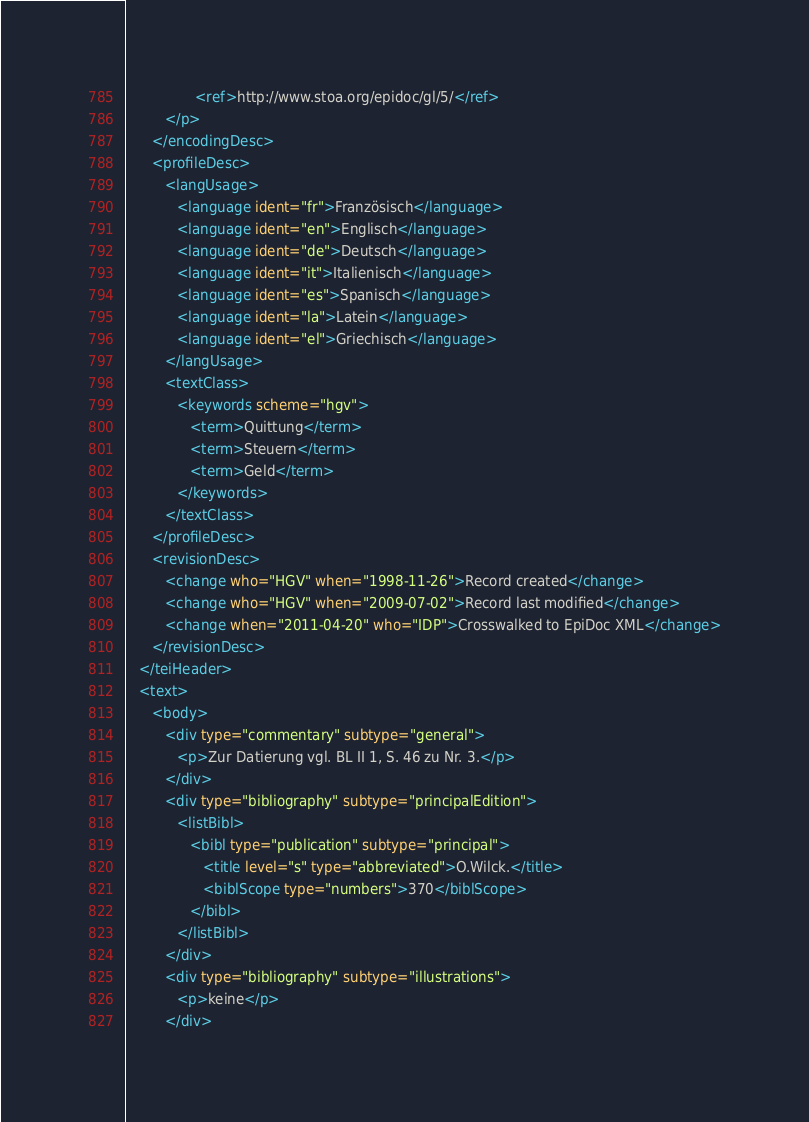<code> <loc_0><loc_0><loc_500><loc_500><_XML_>                <ref>http://www.stoa.org/epidoc/gl/5/</ref>
         </p>
      </encodingDesc>
      <profileDesc>
         <langUsage>
            <language ident="fr">Französisch</language>
            <language ident="en">Englisch</language>
            <language ident="de">Deutsch</language>
            <language ident="it">Italienisch</language>
            <language ident="es">Spanisch</language>
            <language ident="la">Latein</language>
            <language ident="el">Griechisch</language>
         </langUsage>
         <textClass>
            <keywords scheme="hgv">
               <term>Quittung</term>
               <term>Steuern</term>
               <term>Geld</term>
            </keywords>
         </textClass>
      </profileDesc>
      <revisionDesc>
         <change who="HGV" when="1998-11-26">Record created</change>
         <change who="HGV" when="2009-07-02">Record last modified</change>
         <change when="2011-04-20" who="IDP">Crosswalked to EpiDoc XML</change>
      </revisionDesc>
   </teiHeader>
   <text>
      <body>
         <div type="commentary" subtype="general">
            <p>Zur Datierung vgl. BL II 1, S. 46 zu Nr. 3.</p>
         </div>
         <div type="bibliography" subtype="principalEdition">
            <listBibl>
               <bibl type="publication" subtype="principal">
                  <title level="s" type="abbreviated">O.Wilck.</title>
                  <biblScope type="numbers">370</biblScope>
               </bibl>
            </listBibl>
         </div>
         <div type="bibliography" subtype="illustrations">
            <p>keine</p>
         </div></code> 